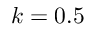Convert formula to latex. <formula><loc_0><loc_0><loc_500><loc_500>k = 0 . 5</formula> 